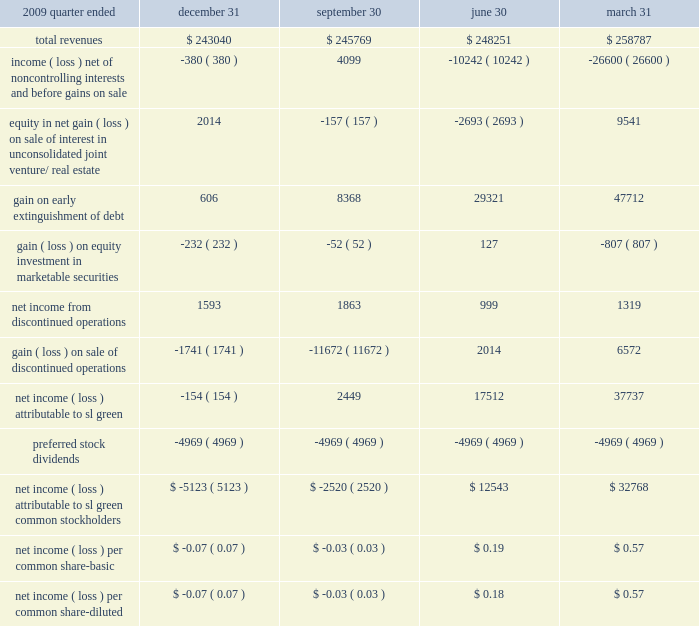22 2002subsequent events in january 2011 , we purchased cif 2019s 49.9% ( 49.9 % ) interest in 521 fifth avenue , thereby assuming full ownership of the building .
The transaction values the consolidated interest at approximately $ 245.7 a0million .
In january 2011 , we repaid our $ 84.8 a0million , 5.15% ( 5.15 % ) unsecured notes at par on their maturity date .
In january 2011 , we , along with the moinian group , completed the recapitalization of 3 columbus circle .
The recapitalization included a $ 138 a0million equity investment by sl a0green , a portion of which was in the form of sl a0green operating partnership units .
We believe the property is now fully capitalized for all costs necessary to complete the redevelop- ment and lease-up of the building .
The previously existing mortgage has been refinanced with a bridge loan provided by sl a0green and deutsche bank , which we intend to be further refinanced by third-party lenders at a later date .
On february a010 , 2011 , the company and the operating partnership entered into atm equity offering sales agreements with each of merrill lynch , pierce , fenner a0& smith incorporated and morgan stanley a0& a0co .
Incorporated , to sell shares of the company 2019s common stock , from time to time , through a $ 250.0 a0 million 201cat the market 201d equity offering program under which merrill lynch , pierce , fenner a0& smith incorporated and morgan stanley a0& a0co .
Incorporated are acting as sales agents .
As of february a022 , 2011 , we sold approximately 2.0 a0million shares our common stock through the program for aggregate proceeds of $ 144.1 a0million .
2009 quarter ended december a031 september a030 june a030 march a031 .
88 sl green realty corp .
2010 annual report notes to consolidated financial statements .
In 2011 what was the ratio of the recapitalization of 3 columbus circle to the 5.15% ( 5.15 % ) unsecured notes repayment? 
Computations: (138 / 84.8)
Answer: 1.62736. 